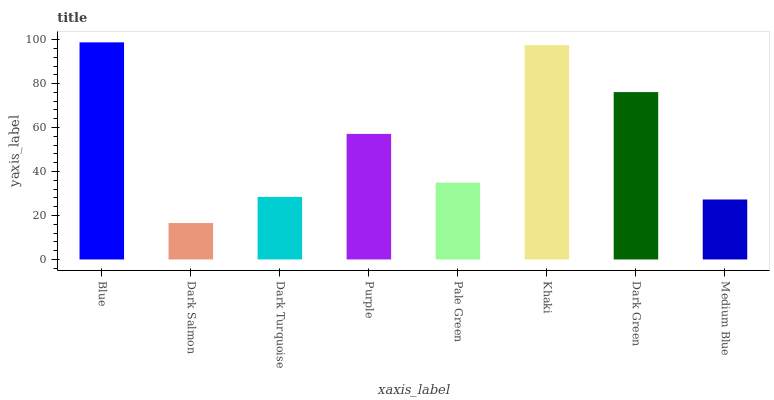Is Dark Turquoise the minimum?
Answer yes or no. No. Is Dark Turquoise the maximum?
Answer yes or no. No. Is Dark Turquoise greater than Dark Salmon?
Answer yes or no. Yes. Is Dark Salmon less than Dark Turquoise?
Answer yes or no. Yes. Is Dark Salmon greater than Dark Turquoise?
Answer yes or no. No. Is Dark Turquoise less than Dark Salmon?
Answer yes or no. No. Is Purple the high median?
Answer yes or no. Yes. Is Pale Green the low median?
Answer yes or no. Yes. Is Pale Green the high median?
Answer yes or no. No. Is Medium Blue the low median?
Answer yes or no. No. 